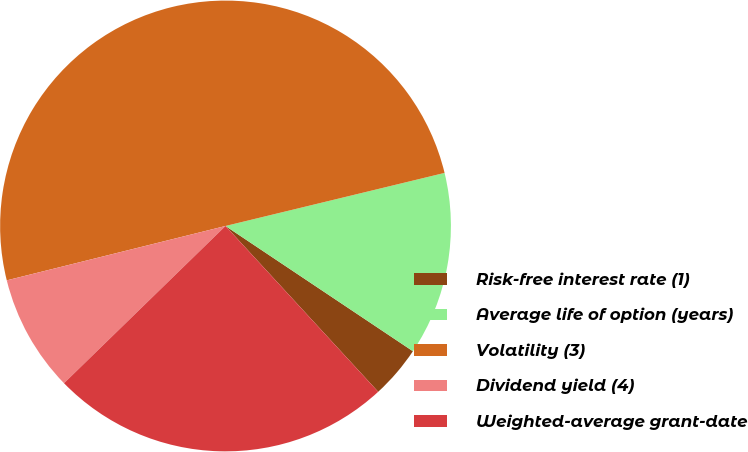<chart> <loc_0><loc_0><loc_500><loc_500><pie_chart><fcel>Risk-free interest rate (1)<fcel>Average life of option (years)<fcel>Volatility (3)<fcel>Dividend yield (4)<fcel>Weighted-average grant-date<nl><fcel>3.78%<fcel>13.16%<fcel>50.1%<fcel>8.41%<fcel>24.56%<nl></chart> 